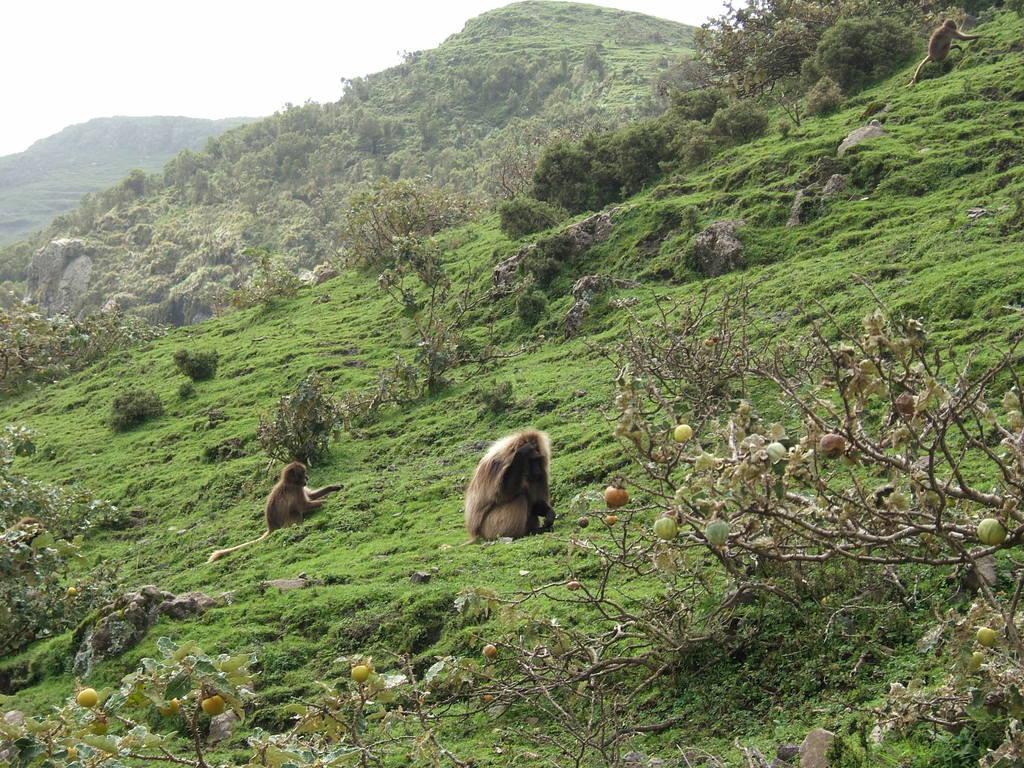Please provide a concise description of this image. In this image I can see two animals are on the ground. To the side I can see the fruits to the tree. In the background I can see many trees, mountains and the white sky. 